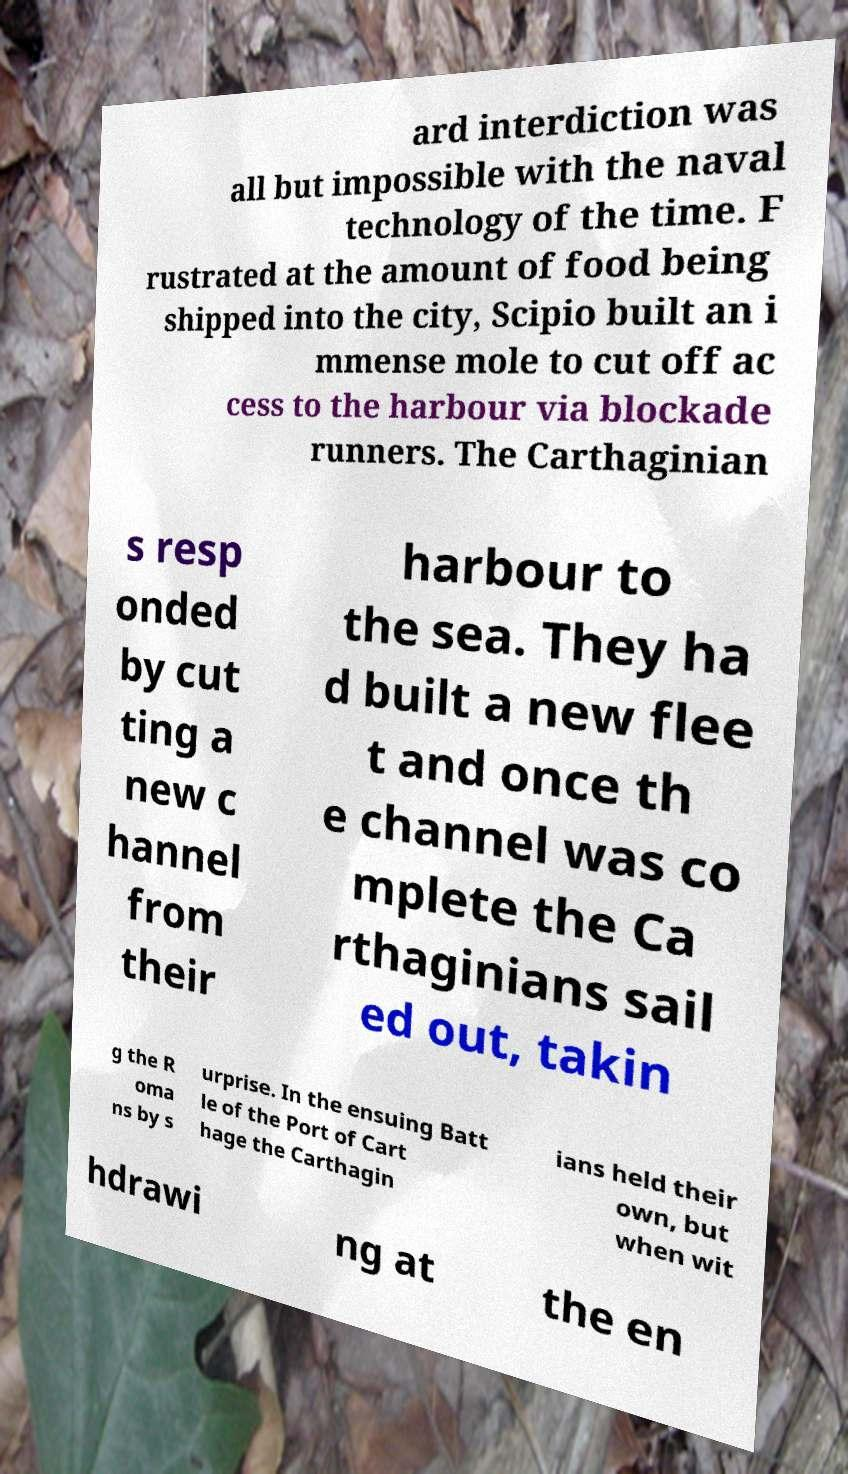Can you accurately transcribe the text from the provided image for me? ard interdiction was all but impossible with the naval technology of the time. F rustrated at the amount of food being shipped into the city, Scipio built an i mmense mole to cut off ac cess to the harbour via blockade runners. The Carthaginian s resp onded by cut ting a new c hannel from their harbour to the sea. They ha d built a new flee t and once th e channel was co mplete the Ca rthaginians sail ed out, takin g the R oma ns by s urprise. In the ensuing Batt le of the Port of Cart hage the Carthagin ians held their own, but when wit hdrawi ng at the en 